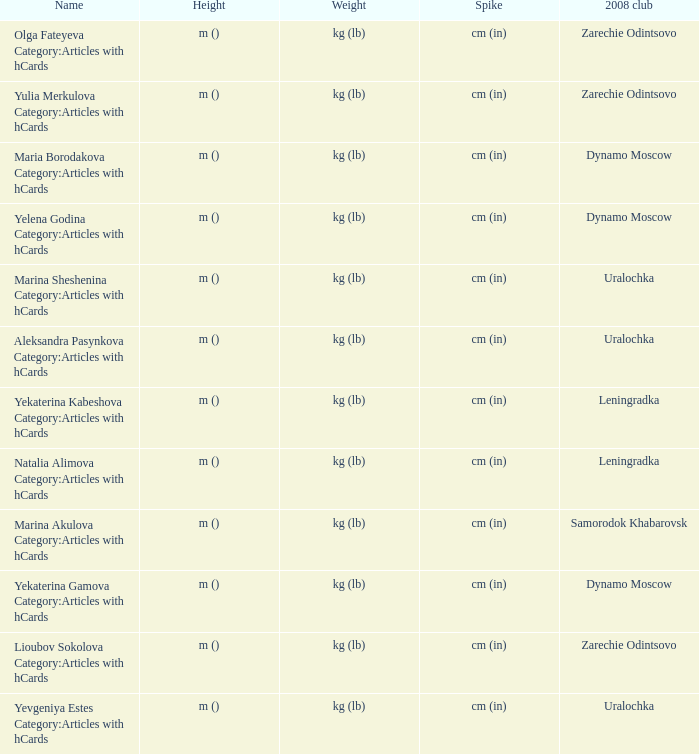What is the name when the 2008 club is uralochka? Yevgeniya Estes Category:Articles with hCards, Marina Sheshenina Category:Articles with hCards, Aleksandra Pasynkova Category:Articles with hCards. 